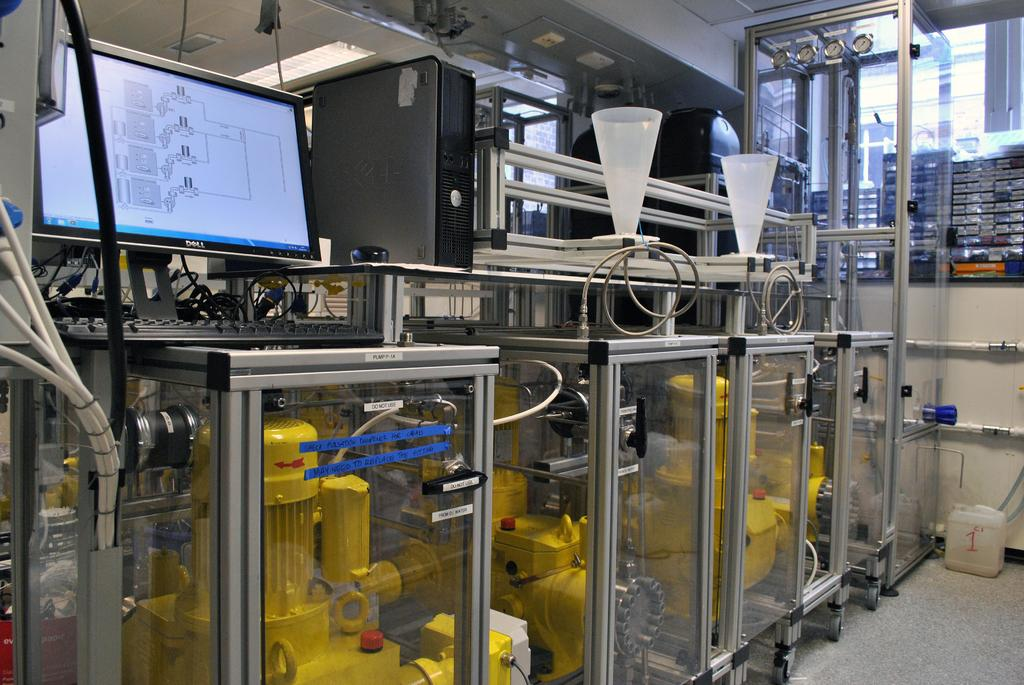What object can be found on the floor in the image? There is a can on the floor in the image. What electronic device is present in the image? There is a monitor in the image. What is used for input in the image? There is a keyboard in the image. What is the main processing unit in the image? There is a CPU in the image. What type of machinery is present in the image? There are motor pumps in the image. Can you describe the unspecified objects in the image? Unfortunately, the facts provided do not give any details about the unspecified objects in the image. What type of quince is being used to test the theory in the image? There is no quince or theory present in the image; it features a can on the floor, a monitor, a keyboard, a CPU, motor pumps, and some unspecified objects. 